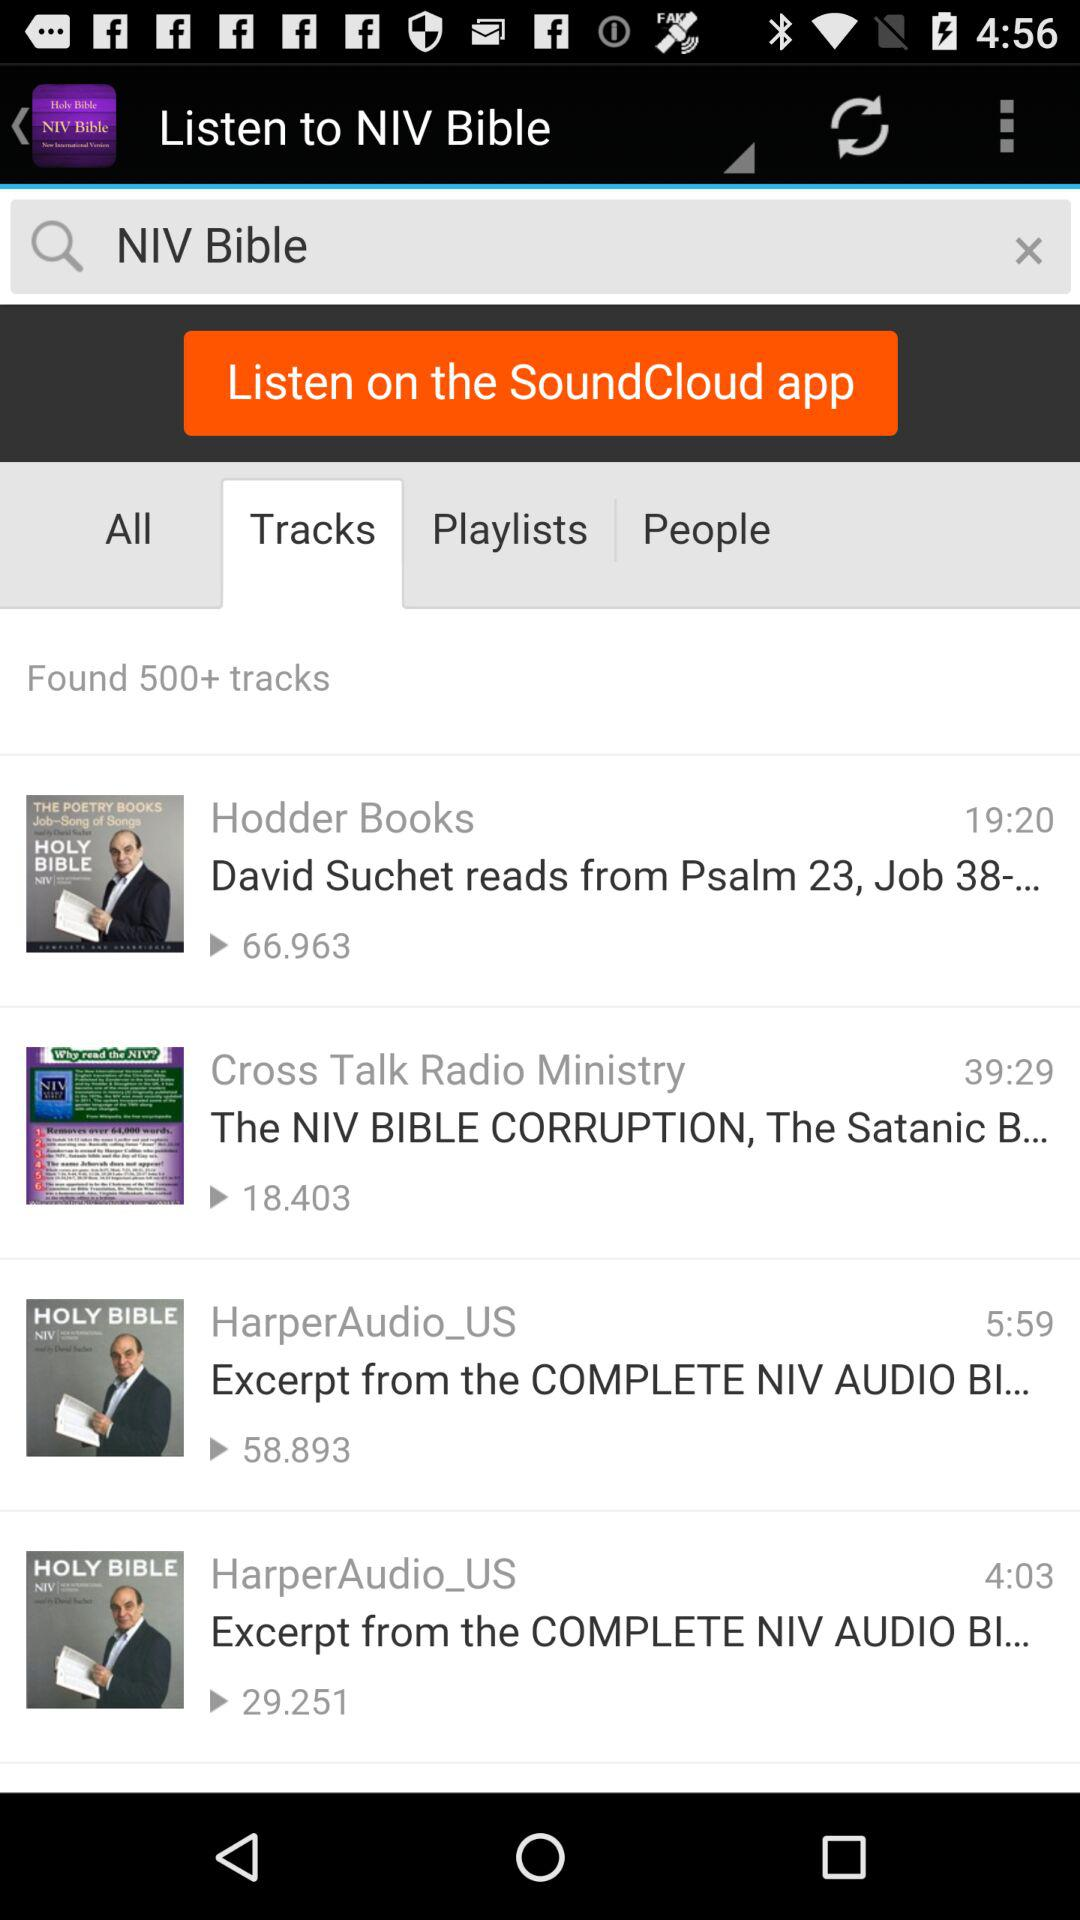What is the entered term in the search bar? The entered term in the search bar is "NIV Bible". 